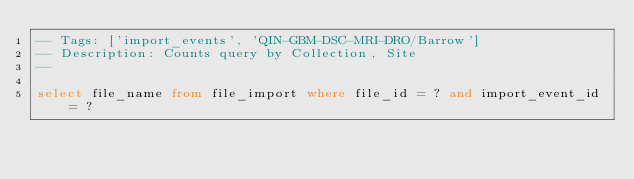<code> <loc_0><loc_0><loc_500><loc_500><_SQL_>-- Tags: ['import_events', 'QIN-GBM-DSC-MRI-DRO/Barrow']
-- Description: Counts query by Collection, Site
-- 

select file_name from file_import where file_id = ? and import_event_id = ?</code> 